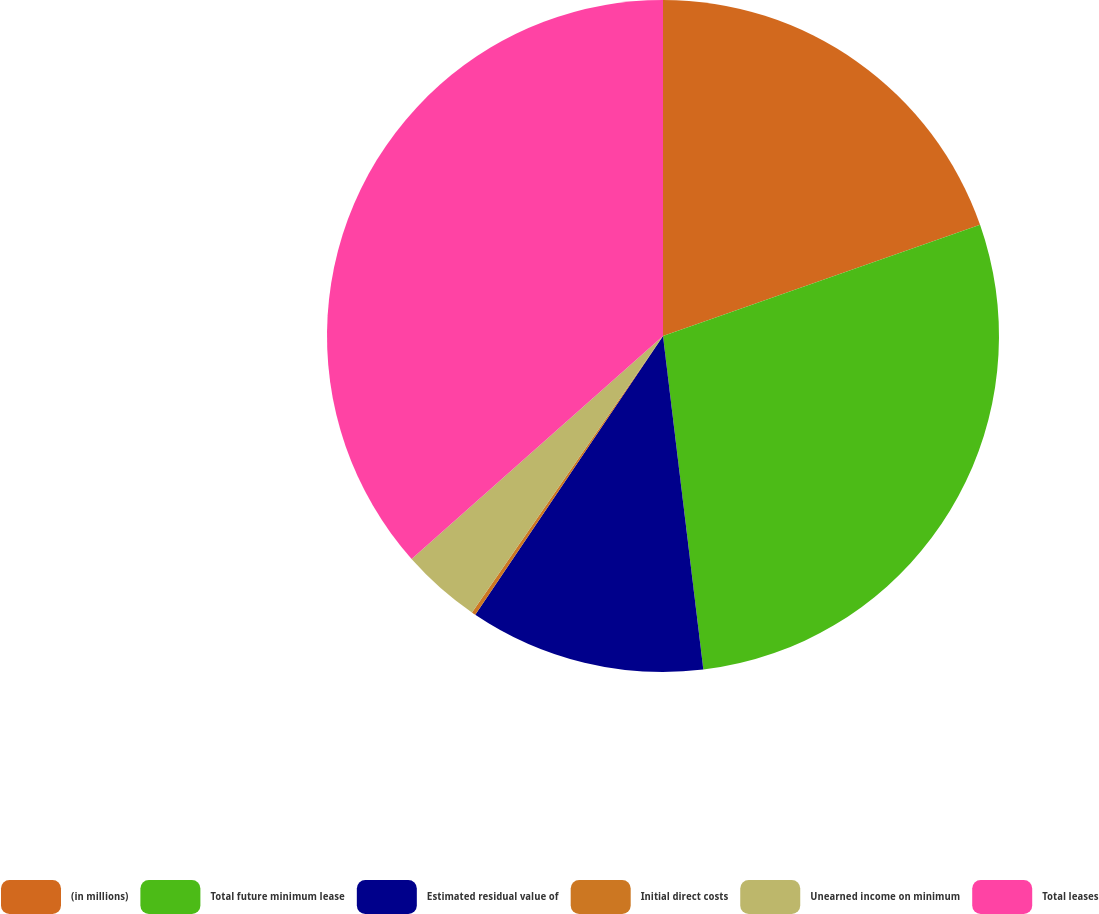<chart> <loc_0><loc_0><loc_500><loc_500><pie_chart><fcel>(in millions)<fcel>Total future minimum lease<fcel>Estimated residual value of<fcel>Initial direct costs<fcel>Unearned income on minimum<fcel>Total leases<nl><fcel>19.63%<fcel>28.45%<fcel>11.35%<fcel>0.19%<fcel>3.83%<fcel>36.54%<nl></chart> 